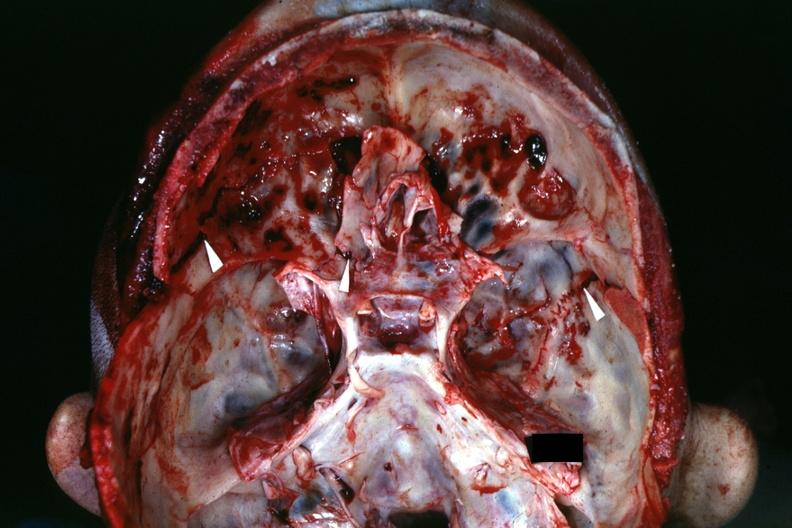what does this image show?
Answer the question using a single word or phrase. View of base of skull with several well shown fractures 